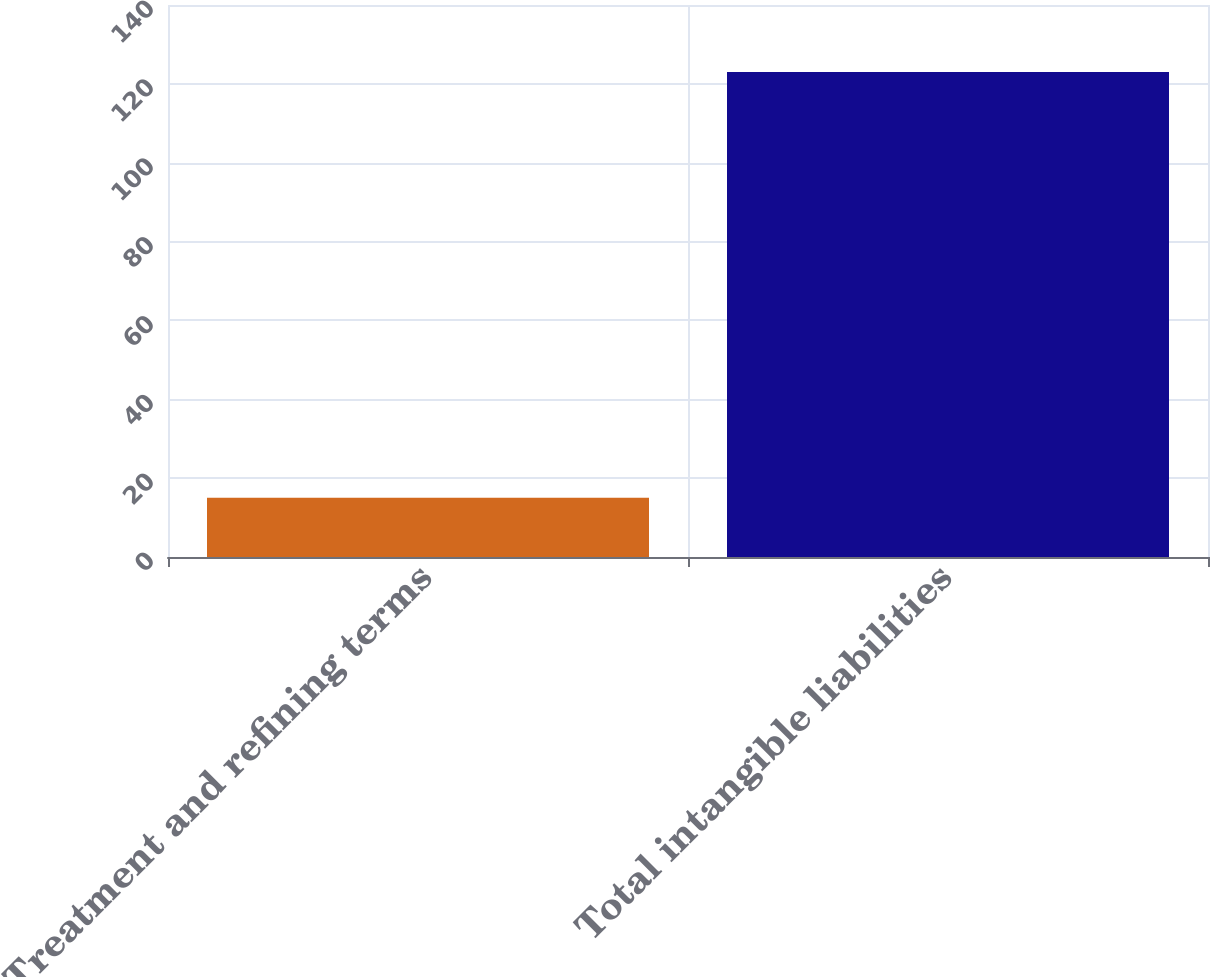Convert chart to OTSL. <chart><loc_0><loc_0><loc_500><loc_500><bar_chart><fcel>Treatment and refining terms<fcel>Total intangible liabilities<nl><fcel>15<fcel>123<nl></chart> 